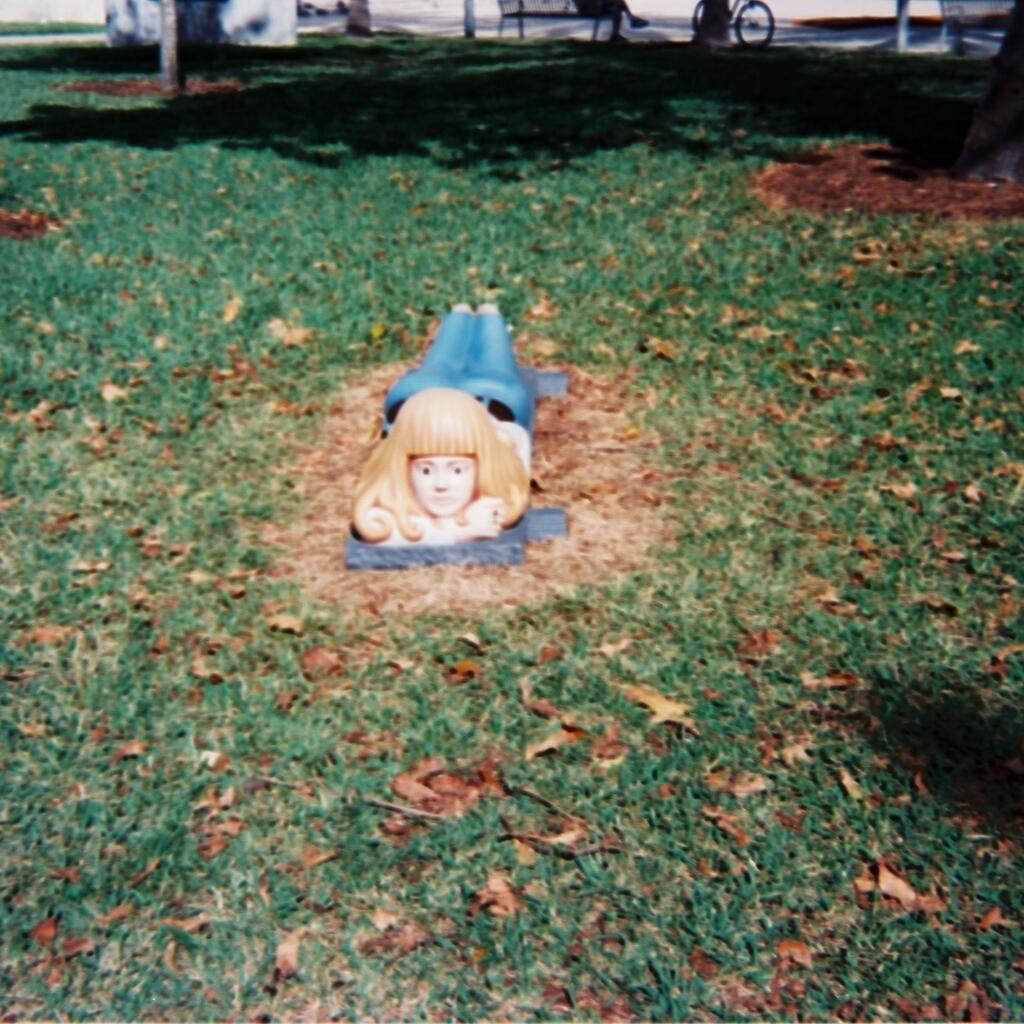Can you describe this image briefly? In this image I can see it looks like a sculpture in the middle. There is the grass in this image. 